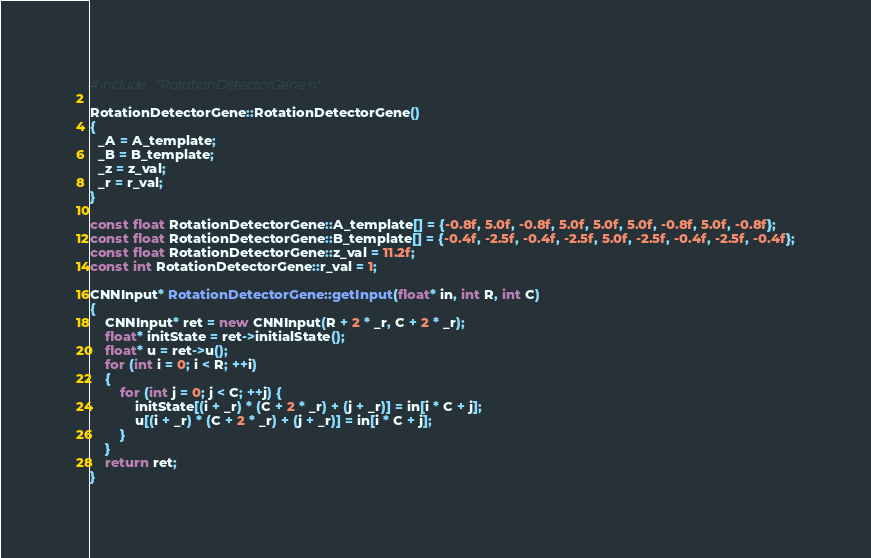<code> <loc_0><loc_0><loc_500><loc_500><_C++_>#include "RotationDetectorGene.h"

RotationDetectorGene::RotationDetectorGene() 
{
  _A = A_template;
  _B = B_template;
  _z = z_val;
  _r = r_val;
}

const float RotationDetectorGene::A_template[] = {-0.8f, 5.0f, -0.8f, 5.0f, 5.0f, 5.0f, -0.8f, 5.0f, -0.8f};
const float RotationDetectorGene::B_template[] = {-0.4f, -2.5f, -0.4f, -2.5f, 5.0f, -2.5f, -0.4f, -2.5f, -0.4f};
const float RotationDetectorGene::z_val = 11.2f;
const int RotationDetectorGene::r_val = 1;

CNNInput* RotationDetectorGene::getInput(float* in, int R, int C)
{
	CNNInput* ret = new CNNInput(R + 2 * _r, C + 2 * _r);
	float* initState = ret->initialState();
	float* u = ret->u();
	for (int i = 0; i < R; ++i)
	{
		for (int j = 0; j < C; ++j) {
			initState[(i + _r) * (C + 2 * _r) + (j + _r)] = in[i * C + j];
			u[(i + _r) * (C + 2 * _r) + (j + _r)] = in[i * C + j];
		}
	}
	return ret;
}
</code> 